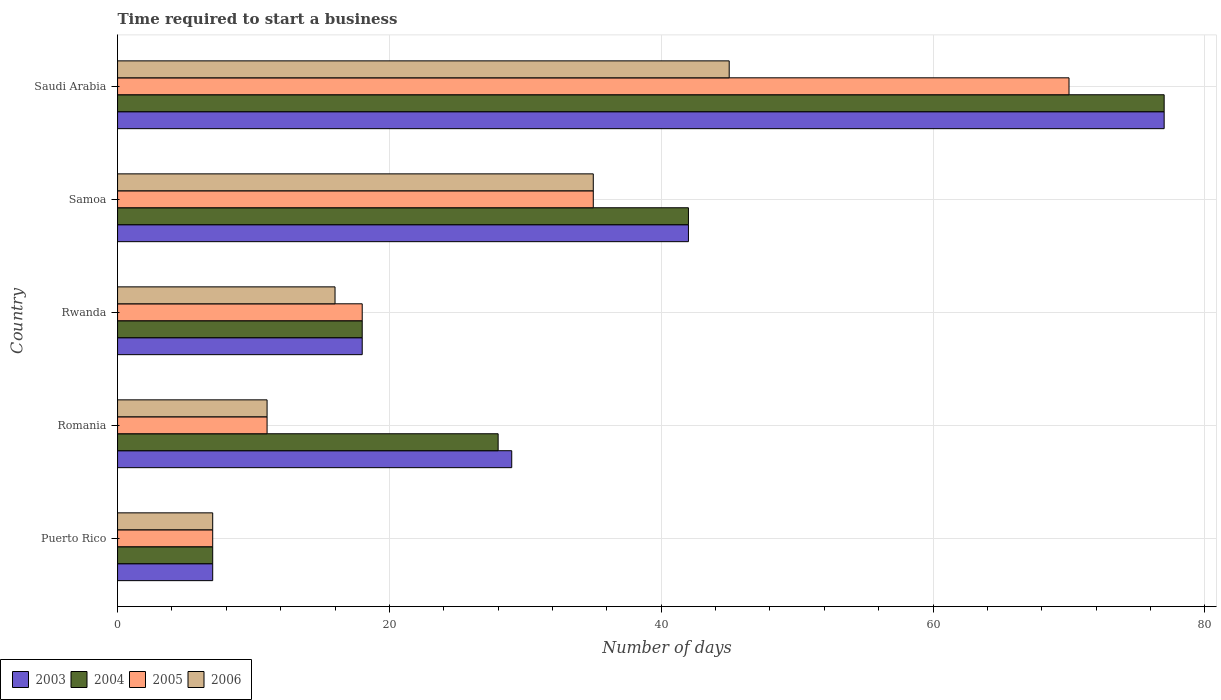How many bars are there on the 3rd tick from the bottom?
Ensure brevity in your answer.  4. What is the label of the 3rd group of bars from the top?
Provide a succinct answer. Rwanda. What is the number of days required to start a business in 2003 in Puerto Rico?
Offer a terse response. 7. Across all countries, what is the maximum number of days required to start a business in 2006?
Provide a succinct answer. 45. In which country was the number of days required to start a business in 2004 maximum?
Your answer should be compact. Saudi Arabia. In which country was the number of days required to start a business in 2004 minimum?
Your response must be concise. Puerto Rico. What is the total number of days required to start a business in 2005 in the graph?
Provide a short and direct response. 141. What is the difference between the number of days required to start a business in 2006 in Romania and that in Saudi Arabia?
Provide a succinct answer. -34. What is the average number of days required to start a business in 2003 per country?
Keep it short and to the point. 34.6. What is the difference between the number of days required to start a business in 2005 and number of days required to start a business in 2006 in Puerto Rico?
Give a very brief answer. 0. In how many countries, is the number of days required to start a business in 2003 greater than 68 days?
Give a very brief answer. 1. What is the ratio of the number of days required to start a business in 2003 in Puerto Rico to that in Romania?
Make the answer very short. 0.24. Is the number of days required to start a business in 2004 in Romania less than that in Saudi Arabia?
Ensure brevity in your answer.  Yes. What is the difference between the highest and the lowest number of days required to start a business in 2003?
Keep it short and to the point. 70. Is it the case that in every country, the sum of the number of days required to start a business in 2005 and number of days required to start a business in 2004 is greater than the sum of number of days required to start a business in 2003 and number of days required to start a business in 2006?
Offer a very short reply. No. What does the 2nd bar from the top in Saudi Arabia represents?
Provide a short and direct response. 2005. Is it the case that in every country, the sum of the number of days required to start a business in 2004 and number of days required to start a business in 2006 is greater than the number of days required to start a business in 2005?
Ensure brevity in your answer.  Yes. How many bars are there?
Your answer should be compact. 20. Are all the bars in the graph horizontal?
Provide a succinct answer. Yes. How many countries are there in the graph?
Ensure brevity in your answer.  5. What is the difference between two consecutive major ticks on the X-axis?
Ensure brevity in your answer.  20. Where does the legend appear in the graph?
Ensure brevity in your answer.  Bottom left. How are the legend labels stacked?
Keep it short and to the point. Horizontal. What is the title of the graph?
Provide a short and direct response. Time required to start a business. What is the label or title of the X-axis?
Your answer should be compact. Number of days. What is the Number of days in 2004 in Puerto Rico?
Your answer should be very brief. 7. What is the Number of days of 2005 in Puerto Rico?
Give a very brief answer. 7. What is the Number of days of 2003 in Romania?
Keep it short and to the point. 29. What is the Number of days of 2004 in Romania?
Provide a short and direct response. 28. What is the Number of days of 2005 in Romania?
Provide a short and direct response. 11. What is the Number of days of 2003 in Rwanda?
Keep it short and to the point. 18. What is the Number of days in 2006 in Rwanda?
Your response must be concise. 16. What is the Number of days in 2003 in Samoa?
Ensure brevity in your answer.  42. What is the Number of days of 2004 in Saudi Arabia?
Provide a short and direct response. 77. What is the Number of days in 2005 in Saudi Arabia?
Give a very brief answer. 70. What is the Number of days of 2006 in Saudi Arabia?
Your answer should be very brief. 45. Across all countries, what is the maximum Number of days of 2004?
Ensure brevity in your answer.  77. Across all countries, what is the maximum Number of days of 2005?
Provide a succinct answer. 70. Across all countries, what is the maximum Number of days of 2006?
Provide a succinct answer. 45. Across all countries, what is the minimum Number of days in 2003?
Your response must be concise. 7. Across all countries, what is the minimum Number of days in 2004?
Your response must be concise. 7. Across all countries, what is the minimum Number of days in 2006?
Keep it short and to the point. 7. What is the total Number of days of 2003 in the graph?
Your response must be concise. 173. What is the total Number of days in 2004 in the graph?
Your answer should be very brief. 172. What is the total Number of days in 2005 in the graph?
Offer a terse response. 141. What is the total Number of days of 2006 in the graph?
Your response must be concise. 114. What is the difference between the Number of days in 2003 in Puerto Rico and that in Rwanda?
Keep it short and to the point. -11. What is the difference between the Number of days in 2006 in Puerto Rico and that in Rwanda?
Offer a terse response. -9. What is the difference between the Number of days of 2003 in Puerto Rico and that in Samoa?
Offer a very short reply. -35. What is the difference between the Number of days of 2004 in Puerto Rico and that in Samoa?
Provide a short and direct response. -35. What is the difference between the Number of days of 2005 in Puerto Rico and that in Samoa?
Provide a short and direct response. -28. What is the difference between the Number of days of 2006 in Puerto Rico and that in Samoa?
Your answer should be compact. -28. What is the difference between the Number of days in 2003 in Puerto Rico and that in Saudi Arabia?
Offer a terse response. -70. What is the difference between the Number of days in 2004 in Puerto Rico and that in Saudi Arabia?
Your answer should be compact. -70. What is the difference between the Number of days of 2005 in Puerto Rico and that in Saudi Arabia?
Make the answer very short. -63. What is the difference between the Number of days in 2006 in Puerto Rico and that in Saudi Arabia?
Offer a very short reply. -38. What is the difference between the Number of days of 2003 in Romania and that in Rwanda?
Keep it short and to the point. 11. What is the difference between the Number of days in 2006 in Romania and that in Rwanda?
Provide a succinct answer. -5. What is the difference between the Number of days of 2003 in Romania and that in Samoa?
Provide a succinct answer. -13. What is the difference between the Number of days of 2004 in Romania and that in Samoa?
Offer a very short reply. -14. What is the difference between the Number of days of 2006 in Romania and that in Samoa?
Your response must be concise. -24. What is the difference between the Number of days of 2003 in Romania and that in Saudi Arabia?
Give a very brief answer. -48. What is the difference between the Number of days of 2004 in Romania and that in Saudi Arabia?
Ensure brevity in your answer.  -49. What is the difference between the Number of days in 2005 in Romania and that in Saudi Arabia?
Ensure brevity in your answer.  -59. What is the difference between the Number of days of 2006 in Romania and that in Saudi Arabia?
Provide a succinct answer. -34. What is the difference between the Number of days of 2003 in Rwanda and that in Samoa?
Keep it short and to the point. -24. What is the difference between the Number of days in 2003 in Rwanda and that in Saudi Arabia?
Offer a terse response. -59. What is the difference between the Number of days in 2004 in Rwanda and that in Saudi Arabia?
Offer a very short reply. -59. What is the difference between the Number of days of 2005 in Rwanda and that in Saudi Arabia?
Your response must be concise. -52. What is the difference between the Number of days of 2003 in Samoa and that in Saudi Arabia?
Your response must be concise. -35. What is the difference between the Number of days of 2004 in Samoa and that in Saudi Arabia?
Provide a short and direct response. -35. What is the difference between the Number of days in 2005 in Samoa and that in Saudi Arabia?
Provide a short and direct response. -35. What is the difference between the Number of days of 2003 in Puerto Rico and the Number of days of 2004 in Romania?
Provide a succinct answer. -21. What is the difference between the Number of days of 2003 in Puerto Rico and the Number of days of 2006 in Romania?
Ensure brevity in your answer.  -4. What is the difference between the Number of days in 2004 in Puerto Rico and the Number of days in 2005 in Romania?
Give a very brief answer. -4. What is the difference between the Number of days in 2004 in Puerto Rico and the Number of days in 2006 in Rwanda?
Your response must be concise. -9. What is the difference between the Number of days in 2003 in Puerto Rico and the Number of days in 2004 in Samoa?
Your response must be concise. -35. What is the difference between the Number of days of 2003 in Puerto Rico and the Number of days of 2006 in Samoa?
Your answer should be compact. -28. What is the difference between the Number of days of 2004 in Puerto Rico and the Number of days of 2006 in Samoa?
Make the answer very short. -28. What is the difference between the Number of days of 2005 in Puerto Rico and the Number of days of 2006 in Samoa?
Ensure brevity in your answer.  -28. What is the difference between the Number of days in 2003 in Puerto Rico and the Number of days in 2004 in Saudi Arabia?
Offer a terse response. -70. What is the difference between the Number of days in 2003 in Puerto Rico and the Number of days in 2005 in Saudi Arabia?
Keep it short and to the point. -63. What is the difference between the Number of days in 2003 in Puerto Rico and the Number of days in 2006 in Saudi Arabia?
Your answer should be very brief. -38. What is the difference between the Number of days in 2004 in Puerto Rico and the Number of days in 2005 in Saudi Arabia?
Offer a very short reply. -63. What is the difference between the Number of days of 2004 in Puerto Rico and the Number of days of 2006 in Saudi Arabia?
Make the answer very short. -38. What is the difference between the Number of days in 2005 in Puerto Rico and the Number of days in 2006 in Saudi Arabia?
Offer a very short reply. -38. What is the difference between the Number of days in 2003 in Romania and the Number of days in 2004 in Rwanda?
Your answer should be very brief. 11. What is the difference between the Number of days in 2004 in Romania and the Number of days in 2006 in Rwanda?
Offer a terse response. 12. What is the difference between the Number of days in 2003 in Romania and the Number of days in 2004 in Samoa?
Your answer should be compact. -13. What is the difference between the Number of days of 2004 in Romania and the Number of days of 2005 in Samoa?
Your response must be concise. -7. What is the difference between the Number of days in 2005 in Romania and the Number of days in 2006 in Samoa?
Your answer should be compact. -24. What is the difference between the Number of days of 2003 in Romania and the Number of days of 2004 in Saudi Arabia?
Provide a succinct answer. -48. What is the difference between the Number of days in 2003 in Romania and the Number of days in 2005 in Saudi Arabia?
Make the answer very short. -41. What is the difference between the Number of days of 2004 in Romania and the Number of days of 2005 in Saudi Arabia?
Provide a succinct answer. -42. What is the difference between the Number of days of 2005 in Romania and the Number of days of 2006 in Saudi Arabia?
Make the answer very short. -34. What is the difference between the Number of days in 2005 in Rwanda and the Number of days in 2006 in Samoa?
Provide a succinct answer. -17. What is the difference between the Number of days in 2003 in Rwanda and the Number of days in 2004 in Saudi Arabia?
Ensure brevity in your answer.  -59. What is the difference between the Number of days of 2003 in Rwanda and the Number of days of 2005 in Saudi Arabia?
Give a very brief answer. -52. What is the difference between the Number of days in 2004 in Rwanda and the Number of days in 2005 in Saudi Arabia?
Provide a short and direct response. -52. What is the difference between the Number of days in 2003 in Samoa and the Number of days in 2004 in Saudi Arabia?
Keep it short and to the point. -35. What is the difference between the Number of days in 2003 in Samoa and the Number of days in 2005 in Saudi Arabia?
Offer a very short reply. -28. What is the difference between the Number of days of 2003 in Samoa and the Number of days of 2006 in Saudi Arabia?
Your answer should be compact. -3. What is the difference between the Number of days of 2004 in Samoa and the Number of days of 2005 in Saudi Arabia?
Your answer should be compact. -28. What is the difference between the Number of days of 2004 in Samoa and the Number of days of 2006 in Saudi Arabia?
Your answer should be very brief. -3. What is the average Number of days in 2003 per country?
Offer a terse response. 34.6. What is the average Number of days in 2004 per country?
Make the answer very short. 34.4. What is the average Number of days in 2005 per country?
Offer a very short reply. 28.2. What is the average Number of days in 2006 per country?
Your response must be concise. 22.8. What is the difference between the Number of days of 2003 and Number of days of 2006 in Puerto Rico?
Make the answer very short. 0. What is the difference between the Number of days of 2005 and Number of days of 2006 in Puerto Rico?
Make the answer very short. 0. What is the difference between the Number of days in 2003 and Number of days in 2004 in Romania?
Your answer should be very brief. 1. What is the difference between the Number of days of 2003 and Number of days of 2004 in Rwanda?
Ensure brevity in your answer.  0. What is the difference between the Number of days of 2004 and Number of days of 2006 in Rwanda?
Your answer should be compact. 2. What is the difference between the Number of days in 2003 and Number of days in 2004 in Samoa?
Offer a very short reply. 0. What is the difference between the Number of days in 2003 and Number of days in 2006 in Samoa?
Your answer should be compact. 7. What is the difference between the Number of days of 2004 and Number of days of 2006 in Samoa?
Your answer should be very brief. 7. What is the difference between the Number of days of 2005 and Number of days of 2006 in Samoa?
Provide a succinct answer. 0. What is the difference between the Number of days of 2004 and Number of days of 2006 in Saudi Arabia?
Your answer should be compact. 32. What is the ratio of the Number of days in 2003 in Puerto Rico to that in Romania?
Ensure brevity in your answer.  0.24. What is the ratio of the Number of days in 2004 in Puerto Rico to that in Romania?
Your response must be concise. 0.25. What is the ratio of the Number of days of 2005 in Puerto Rico to that in Romania?
Keep it short and to the point. 0.64. What is the ratio of the Number of days in 2006 in Puerto Rico to that in Romania?
Your answer should be compact. 0.64. What is the ratio of the Number of days of 2003 in Puerto Rico to that in Rwanda?
Your response must be concise. 0.39. What is the ratio of the Number of days of 2004 in Puerto Rico to that in Rwanda?
Make the answer very short. 0.39. What is the ratio of the Number of days of 2005 in Puerto Rico to that in Rwanda?
Your answer should be compact. 0.39. What is the ratio of the Number of days in 2006 in Puerto Rico to that in Rwanda?
Give a very brief answer. 0.44. What is the ratio of the Number of days of 2003 in Puerto Rico to that in Saudi Arabia?
Your response must be concise. 0.09. What is the ratio of the Number of days of 2004 in Puerto Rico to that in Saudi Arabia?
Offer a very short reply. 0.09. What is the ratio of the Number of days in 2006 in Puerto Rico to that in Saudi Arabia?
Provide a succinct answer. 0.16. What is the ratio of the Number of days in 2003 in Romania to that in Rwanda?
Your answer should be very brief. 1.61. What is the ratio of the Number of days in 2004 in Romania to that in Rwanda?
Your response must be concise. 1.56. What is the ratio of the Number of days in 2005 in Romania to that in Rwanda?
Offer a terse response. 0.61. What is the ratio of the Number of days of 2006 in Romania to that in Rwanda?
Make the answer very short. 0.69. What is the ratio of the Number of days of 2003 in Romania to that in Samoa?
Offer a very short reply. 0.69. What is the ratio of the Number of days of 2004 in Romania to that in Samoa?
Your answer should be very brief. 0.67. What is the ratio of the Number of days in 2005 in Romania to that in Samoa?
Make the answer very short. 0.31. What is the ratio of the Number of days of 2006 in Romania to that in Samoa?
Make the answer very short. 0.31. What is the ratio of the Number of days of 2003 in Romania to that in Saudi Arabia?
Your answer should be compact. 0.38. What is the ratio of the Number of days of 2004 in Romania to that in Saudi Arabia?
Provide a succinct answer. 0.36. What is the ratio of the Number of days in 2005 in Romania to that in Saudi Arabia?
Give a very brief answer. 0.16. What is the ratio of the Number of days in 2006 in Romania to that in Saudi Arabia?
Keep it short and to the point. 0.24. What is the ratio of the Number of days of 2003 in Rwanda to that in Samoa?
Make the answer very short. 0.43. What is the ratio of the Number of days of 2004 in Rwanda to that in Samoa?
Your answer should be compact. 0.43. What is the ratio of the Number of days in 2005 in Rwanda to that in Samoa?
Offer a very short reply. 0.51. What is the ratio of the Number of days of 2006 in Rwanda to that in Samoa?
Provide a succinct answer. 0.46. What is the ratio of the Number of days of 2003 in Rwanda to that in Saudi Arabia?
Provide a succinct answer. 0.23. What is the ratio of the Number of days in 2004 in Rwanda to that in Saudi Arabia?
Provide a short and direct response. 0.23. What is the ratio of the Number of days in 2005 in Rwanda to that in Saudi Arabia?
Offer a very short reply. 0.26. What is the ratio of the Number of days of 2006 in Rwanda to that in Saudi Arabia?
Give a very brief answer. 0.36. What is the ratio of the Number of days in 2003 in Samoa to that in Saudi Arabia?
Keep it short and to the point. 0.55. What is the ratio of the Number of days of 2004 in Samoa to that in Saudi Arabia?
Provide a short and direct response. 0.55. What is the difference between the highest and the second highest Number of days of 2003?
Make the answer very short. 35. What is the difference between the highest and the second highest Number of days in 2004?
Keep it short and to the point. 35. 